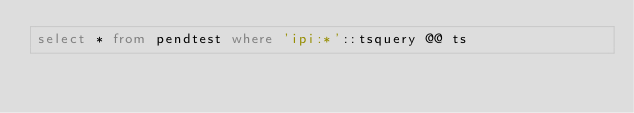<code> <loc_0><loc_0><loc_500><loc_500><_SQL_>select * from pendtest where 'ipi:*'::tsquery @@ ts
</code> 